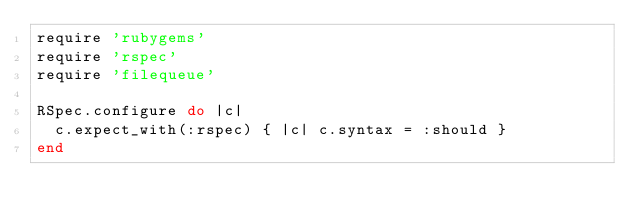Convert code to text. <code><loc_0><loc_0><loc_500><loc_500><_Ruby_>require 'rubygems'
require 'rspec'
require 'filequeue'

RSpec.configure do |c|
  c.expect_with(:rspec) { |c| c.syntax = :should }
end
</code> 